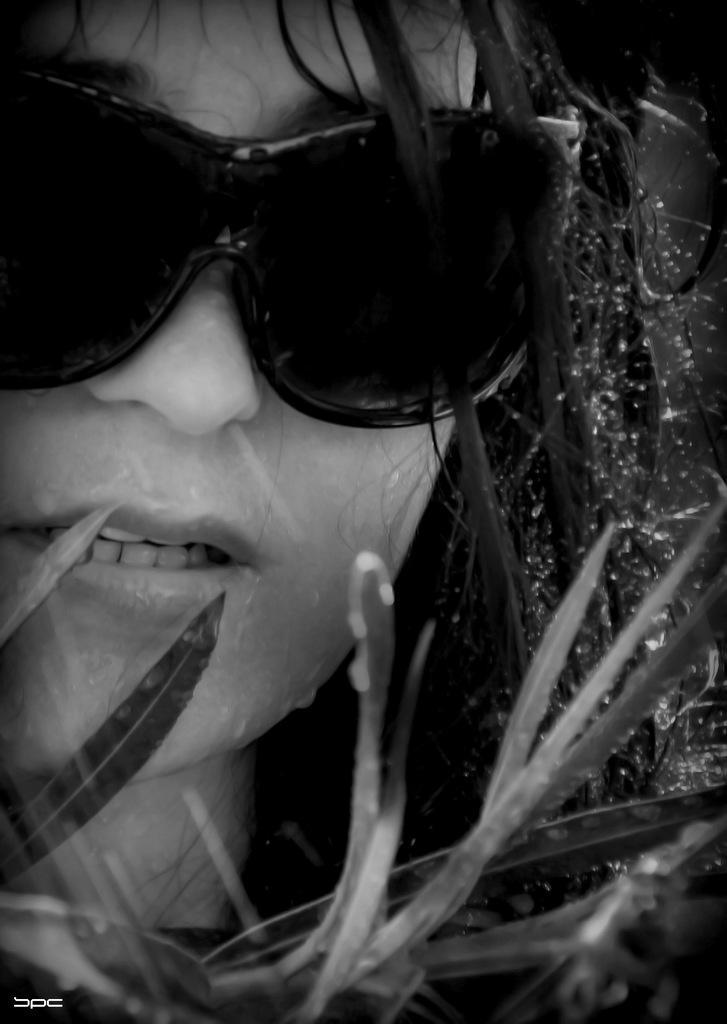In one or two sentences, can you explain what this image depicts? In this picture I can observe a girl. She is wearing spectacles. In front of her I can observe some leaves of a plant. 